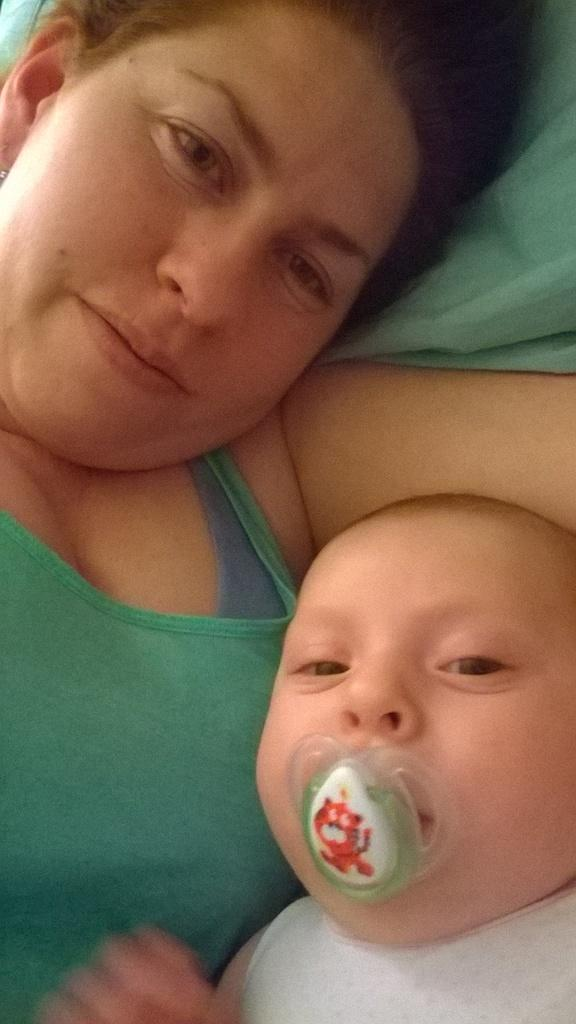Who is present in the image? There is a woman and a baby in the image. What are they doing in the image? Both the woman and the baby are laying on a bed. Where is the bed located in the image? The bed is in the center of the image. How many apples can be seen in the image? There are no apples present in the image. What is the baby's hearing like in the image? There is no information about the baby's hearing in the image. 